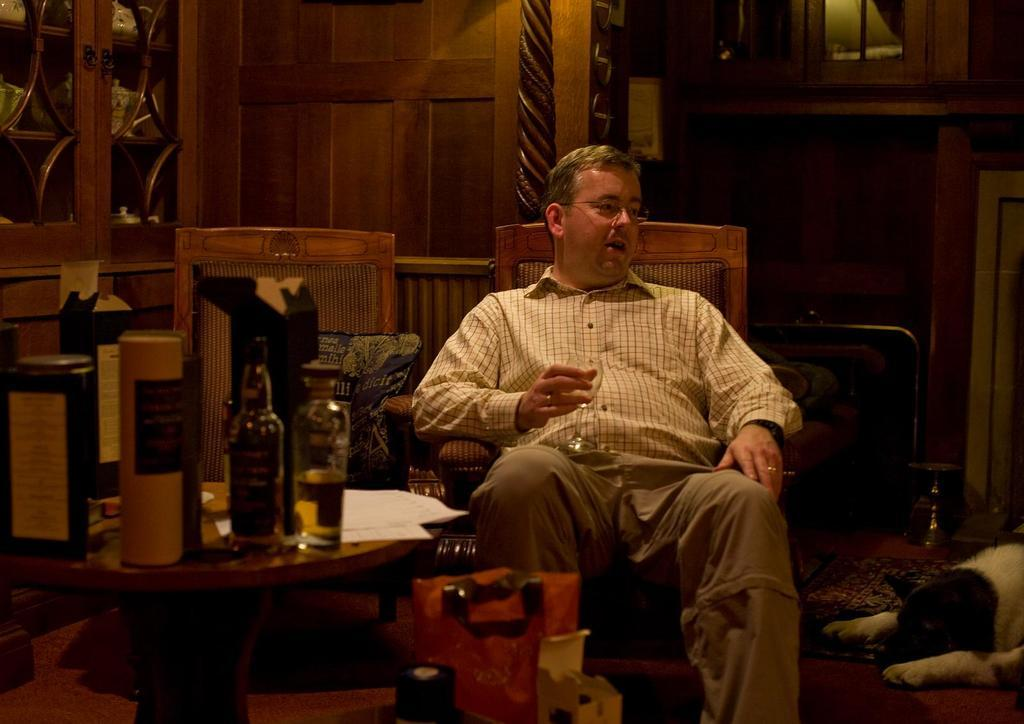What is the man in the image doing? The man is sitting on a chair in the image. What is the man holding in his hand? The man is holding a glass in his hand. What can be seen on the right side of the image? There is a dog on the right side of the image. What type of furniture is present in the image? There is a wooden table in the image. What items are on the wooden table? Wine bottles are present on the table. What is the price of the sidewalk in the image? There is no sidewalk present in the image, so it is not possible to determine its price. 